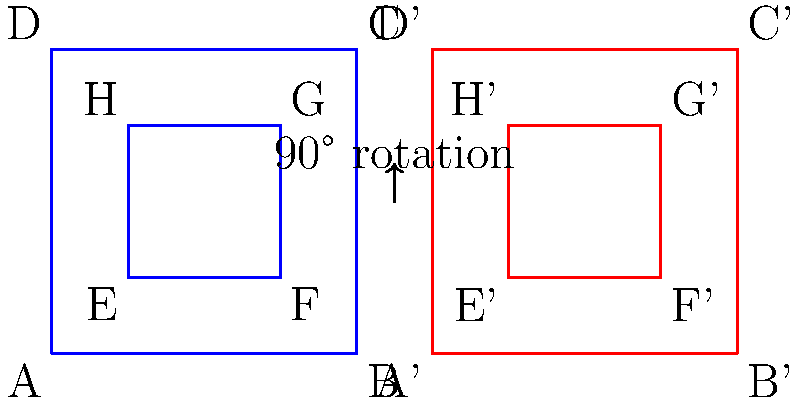At a Celine Dion concert, you're given a seating chart and asked to rotate it 90 degrees clockwise for a new stage setup. The original chart is shown in blue, and the rotated chart is in red. If point E has coordinates (1,1) in the original chart, what are the coordinates of point E' in the rotated chart? To solve this problem, we need to understand how 90-degree clockwise rotation affects coordinates:

1. In a 90-degree clockwise rotation, (x,y) becomes (y,-x).
2. The original point E has coordinates (1,1).
3. Applying the rotation rule:
   - The new x-coordinate will be the original y-coordinate: 1
   - The new y-coordinate will be the negative of the original x-coordinate: -1
4. However, we need to adjust for the shift in the origin of the new chart:
   - The rotated chart is moved 5 units to the right
   - So we add 5 to the x-coordinate: 1 + 5 = 6
5. Therefore, the coordinates of E' are (6,-1)
6. But since the chart uses positive coordinates, we need to adjust the y-coordinate:
   - The height of the chart is 4 units
   - So the actual y-coordinate will be: 4 - 1 = 3

Thus, the final coordinates of E' are (6,3).
Answer: (6,3) 